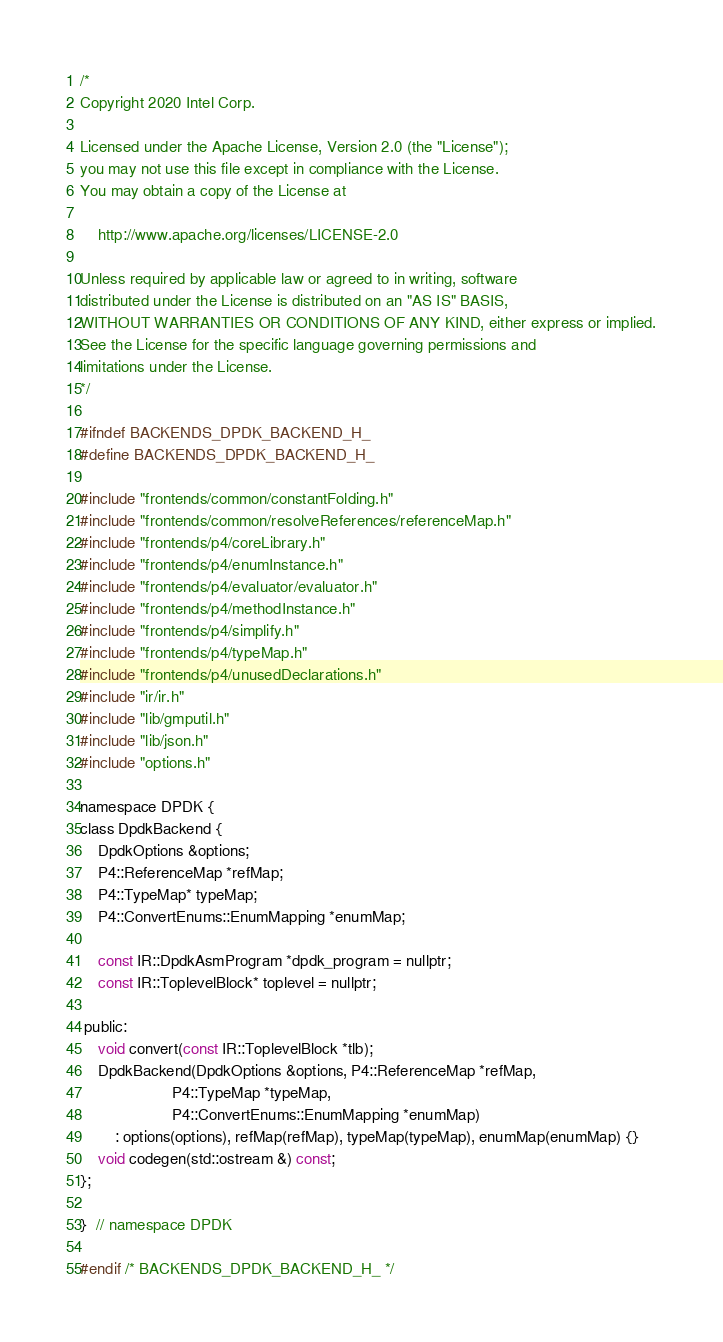Convert code to text. <code><loc_0><loc_0><loc_500><loc_500><_C_>/*
Copyright 2020 Intel Corp.

Licensed under the Apache License, Version 2.0 (the "License");
you may not use this file except in compliance with the License.
You may obtain a copy of the License at

    http://www.apache.org/licenses/LICENSE-2.0

Unless required by applicable law or agreed to in writing, software
distributed under the License is distributed on an "AS IS" BASIS,
WITHOUT WARRANTIES OR CONDITIONS OF ANY KIND, either express or implied.
See the License for the specific language governing permissions and
limitations under the License.
*/

#ifndef BACKENDS_DPDK_BACKEND_H_
#define BACKENDS_DPDK_BACKEND_H_

#include "frontends/common/constantFolding.h"
#include "frontends/common/resolveReferences/referenceMap.h"
#include "frontends/p4/coreLibrary.h"
#include "frontends/p4/enumInstance.h"
#include "frontends/p4/evaluator/evaluator.h"
#include "frontends/p4/methodInstance.h"
#include "frontends/p4/simplify.h"
#include "frontends/p4/typeMap.h"
#include "frontends/p4/unusedDeclarations.h"
#include "ir/ir.h"
#include "lib/gmputil.h"
#include "lib/json.h"
#include "options.h"

namespace DPDK {
class DpdkBackend {
    DpdkOptions &options;
    P4::ReferenceMap *refMap;
    P4::TypeMap* typeMap;
    P4::ConvertEnums::EnumMapping *enumMap;

    const IR::DpdkAsmProgram *dpdk_program = nullptr;
    const IR::ToplevelBlock* toplevel = nullptr;

 public:
    void convert(const IR::ToplevelBlock *tlb);
    DpdkBackend(DpdkOptions &options, P4::ReferenceMap *refMap,
                     P4::TypeMap *typeMap,
                     P4::ConvertEnums::EnumMapping *enumMap)
        : options(options), refMap(refMap), typeMap(typeMap), enumMap(enumMap) {}
    void codegen(std::ostream &) const;
};

}  // namespace DPDK

#endif /* BACKENDS_DPDK_BACKEND_H_ */
</code> 